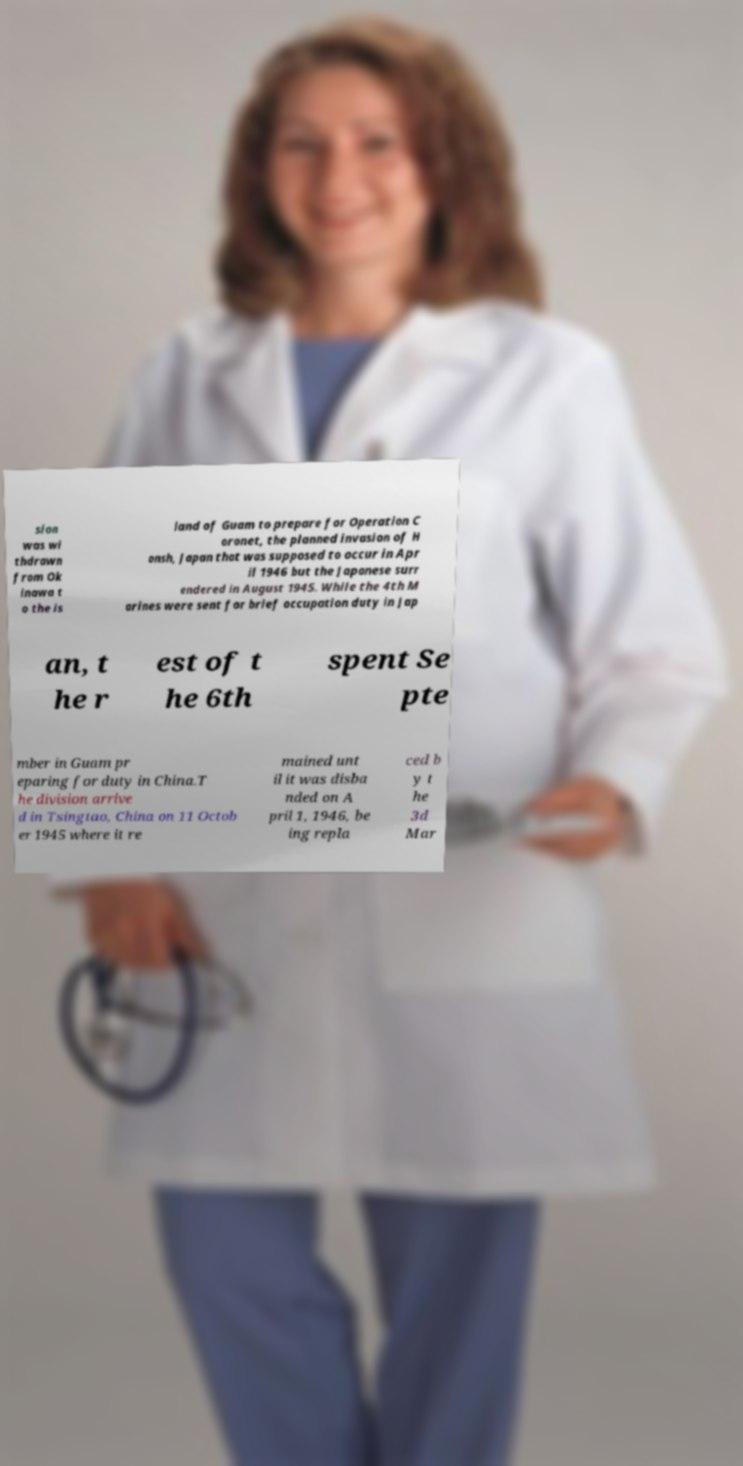Can you read and provide the text displayed in the image?This photo seems to have some interesting text. Can you extract and type it out for me? sion was wi thdrawn from Ok inawa t o the is land of Guam to prepare for Operation C oronet, the planned invasion of H onsh, Japan that was supposed to occur in Apr il 1946 but the Japanese surr endered in August 1945. While the 4th M arines were sent for brief occupation duty in Jap an, t he r est of t he 6th spent Se pte mber in Guam pr eparing for duty in China.T he division arrive d in Tsingtao, China on 11 Octob er 1945 where it re mained unt il it was disba nded on A pril 1, 1946, be ing repla ced b y t he 3d Mar 